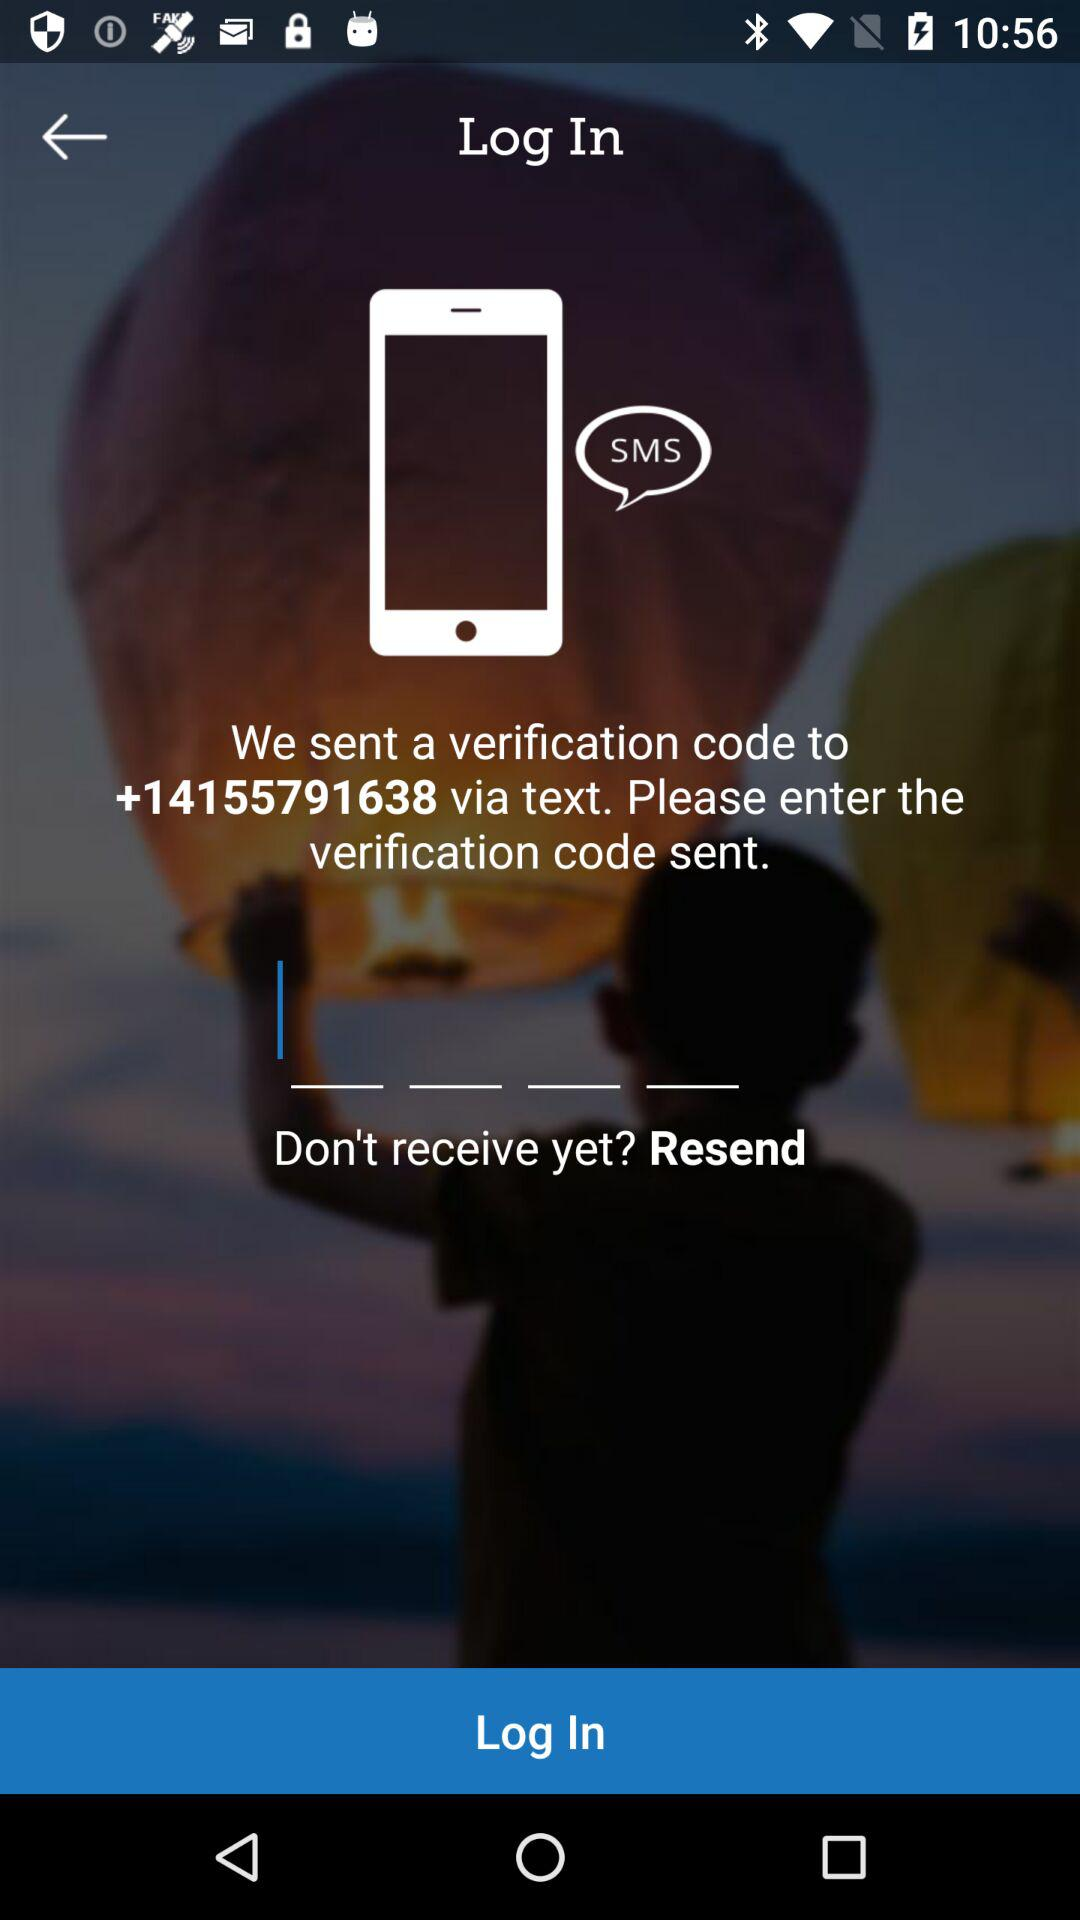What is the contact number? The contact number is +14155791638. 